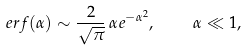Convert formula to latex. <formula><loc_0><loc_0><loc_500><loc_500>\ e r f ( \alpha ) \sim \frac { 2 } { \sqrt { \pi } } \, \alpha e ^ { - \alpha ^ { 2 } } , \quad \alpha \ll 1 ,</formula> 